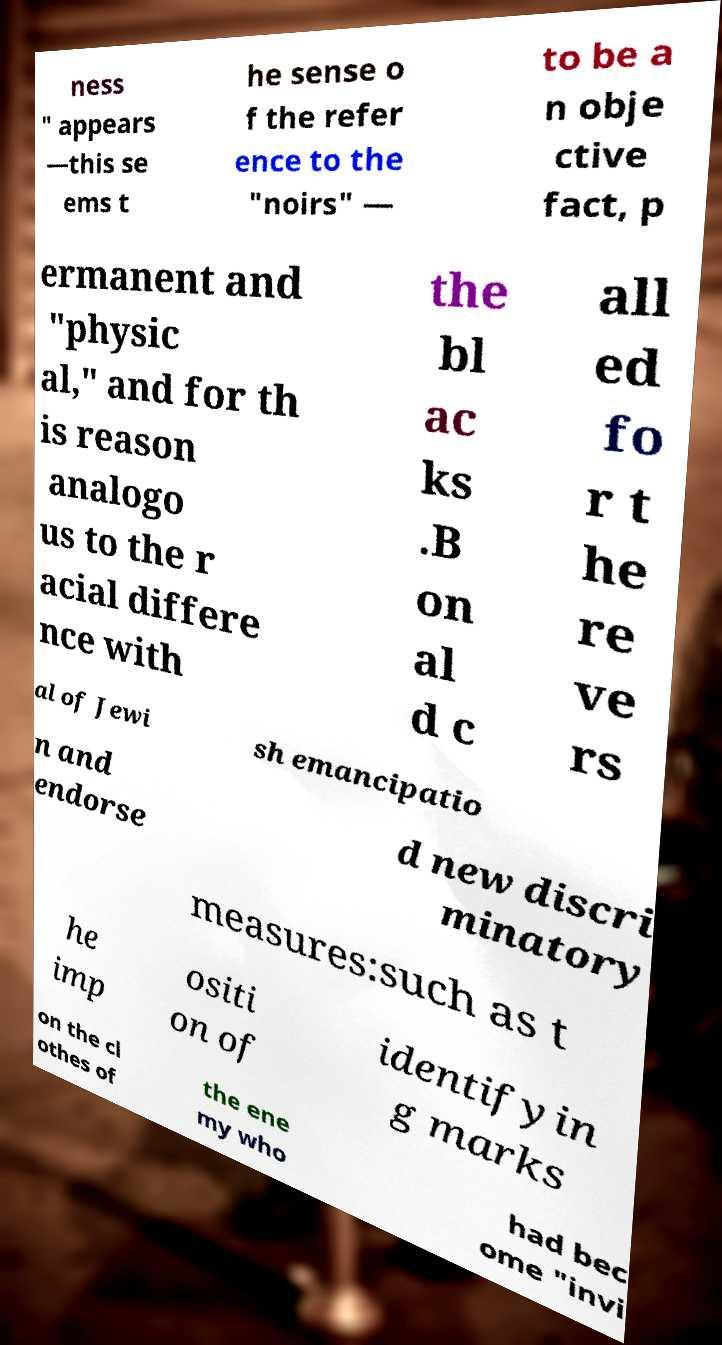For documentation purposes, I need the text within this image transcribed. Could you provide that? ness " appears —this se ems t he sense o f the refer ence to the "noirs" — to be a n obje ctive fact, p ermanent and "physic al," and for th is reason analogo us to the r acial differe nce with the bl ac ks .B on al d c all ed fo r t he re ve rs al of Jewi sh emancipatio n and endorse d new discri minatory measures:such as t he imp ositi on of identifyin g marks on the cl othes of the ene my who had bec ome "invi 